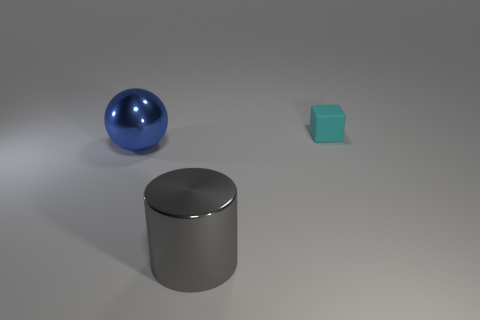Are there any other things that have the same size as the cyan matte thing?
Your answer should be very brief. No. There is a object that is left of the tiny rubber cube and on the right side of the blue metallic sphere; what shape is it?
Your answer should be compact. Cylinder. How many objects are either large things to the right of the large blue sphere or things that are behind the gray thing?
Offer a terse response. 3. What shape is the gray shiny thing?
Your answer should be compact. Cylinder. How many small cyan blocks are the same material as the large cylinder?
Provide a succinct answer. 0. The small block is what color?
Provide a short and direct response. Cyan. There is a metal cylinder that is the same size as the sphere; what color is it?
Provide a short and direct response. Gray. Is there a metallic sphere of the same color as the small thing?
Give a very brief answer. No. There is a metallic thing on the right side of the big blue sphere; is it the same shape as the object that is behind the large blue metallic sphere?
Your response must be concise. No. What number of other things are there of the same size as the cyan rubber block?
Make the answer very short. 0. 